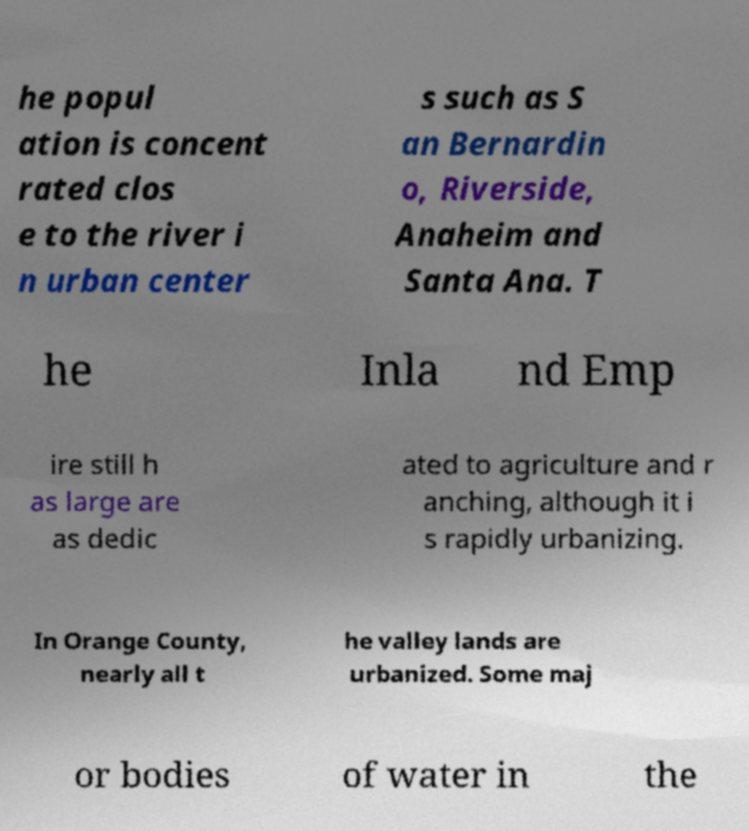Can you read and provide the text displayed in the image?This photo seems to have some interesting text. Can you extract and type it out for me? he popul ation is concent rated clos e to the river i n urban center s such as S an Bernardin o, Riverside, Anaheim and Santa Ana. T he Inla nd Emp ire still h as large are as dedic ated to agriculture and r anching, although it i s rapidly urbanizing. In Orange County, nearly all t he valley lands are urbanized. Some maj or bodies of water in the 